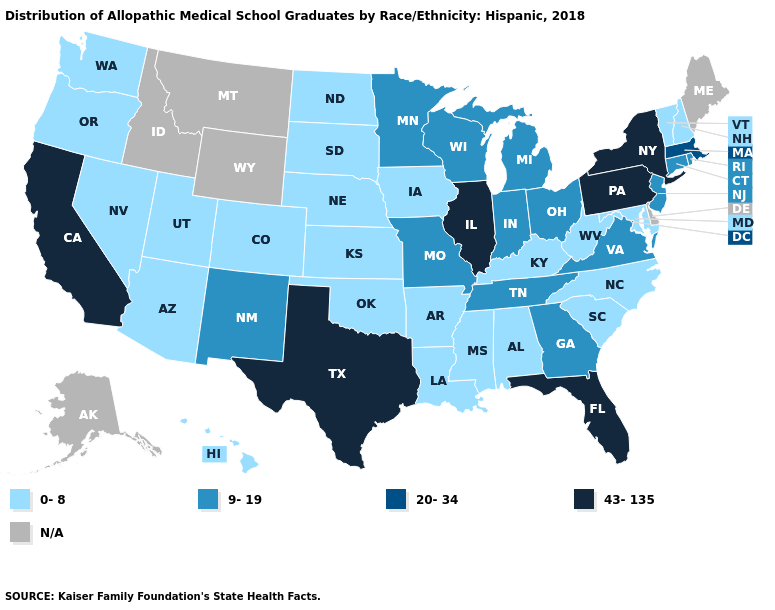How many symbols are there in the legend?
Write a very short answer. 5. Name the states that have a value in the range 43-135?
Short answer required. California, Florida, Illinois, New York, Pennsylvania, Texas. Name the states that have a value in the range 43-135?
Concise answer only. California, Florida, Illinois, New York, Pennsylvania, Texas. What is the value of Wisconsin?
Concise answer only. 9-19. Does South Dakota have the lowest value in the USA?
Be succinct. Yes. How many symbols are there in the legend?
Quick response, please. 5. Name the states that have a value in the range 9-19?
Quick response, please. Connecticut, Georgia, Indiana, Michigan, Minnesota, Missouri, New Jersey, New Mexico, Ohio, Rhode Island, Tennessee, Virginia, Wisconsin. What is the highest value in the MidWest ?
Quick response, please. 43-135. What is the highest value in states that border Utah?
Give a very brief answer. 9-19. Does Oklahoma have the highest value in the South?
Write a very short answer. No. What is the value of Texas?
Answer briefly. 43-135. Does the map have missing data?
Answer briefly. Yes. Name the states that have a value in the range 20-34?
Short answer required. Massachusetts. 